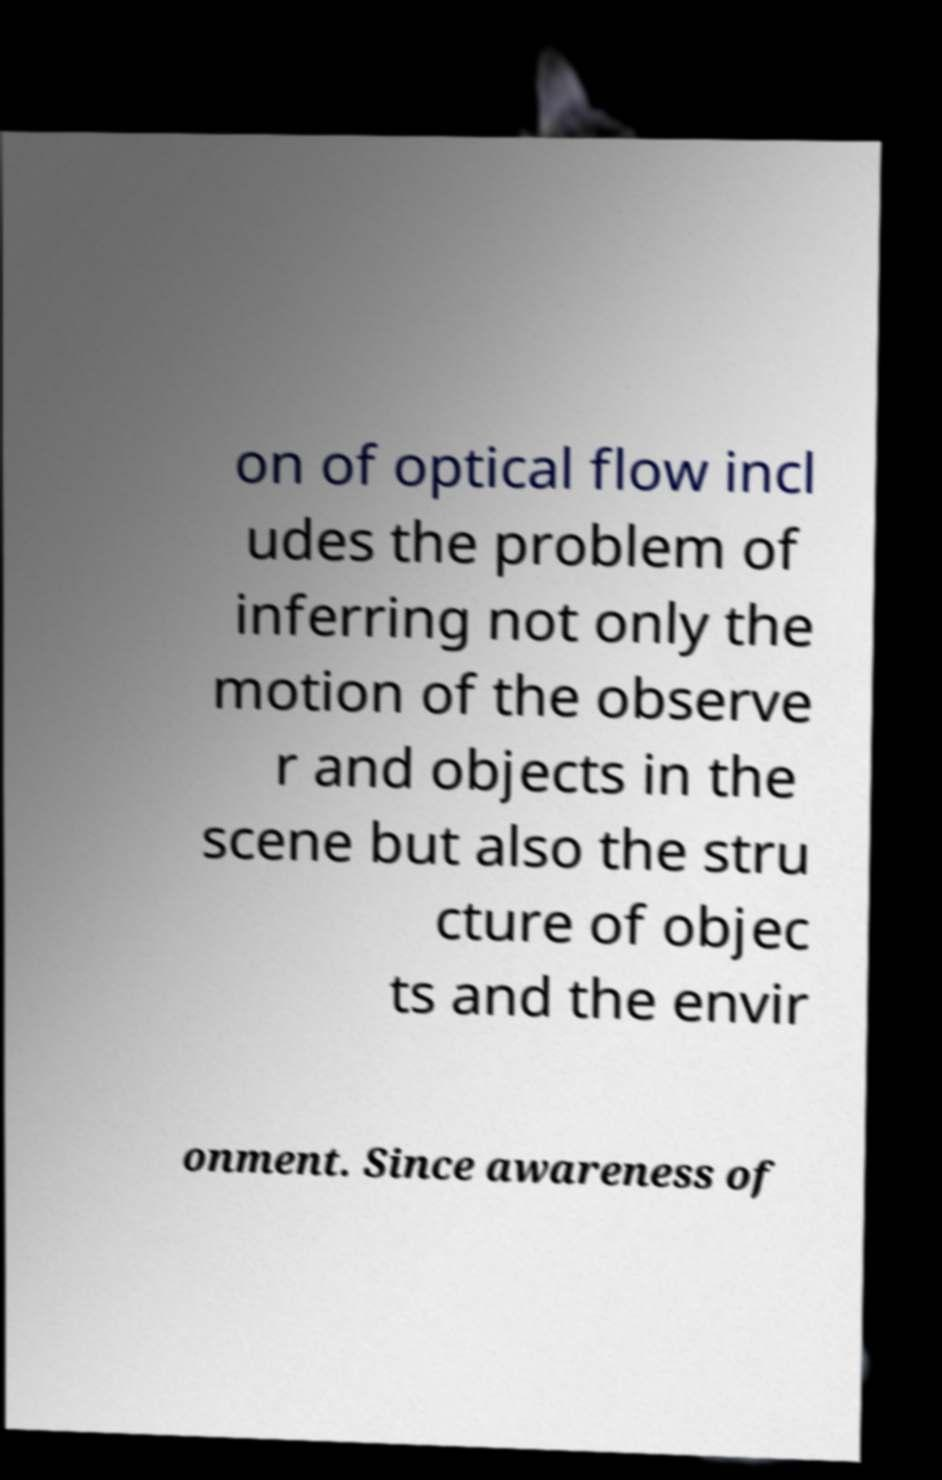There's text embedded in this image that I need extracted. Can you transcribe it verbatim? on of optical flow incl udes the problem of inferring not only the motion of the observe r and objects in the scene but also the stru cture of objec ts and the envir onment. Since awareness of 